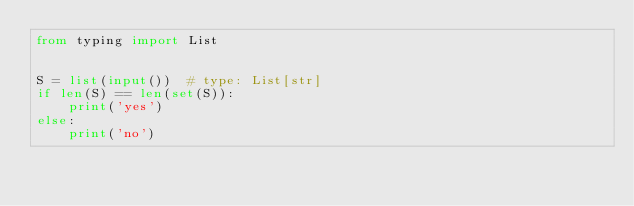Convert code to text. <code><loc_0><loc_0><loc_500><loc_500><_Python_>from typing import List


S = list(input())  # type: List[str]
if len(S) == len(set(S)):
    print('yes')
else:
    print('no')
</code> 